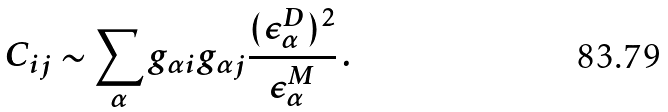Convert formula to latex. <formula><loc_0><loc_0><loc_500><loc_500>C _ { i j } \sim \sum _ { \alpha } g _ { \alpha i } g _ { \alpha j } \frac { ( \epsilon ^ { D } _ { \alpha } ) ^ { 2 } } { \epsilon ^ { M } _ { \alpha } } \, .</formula> 